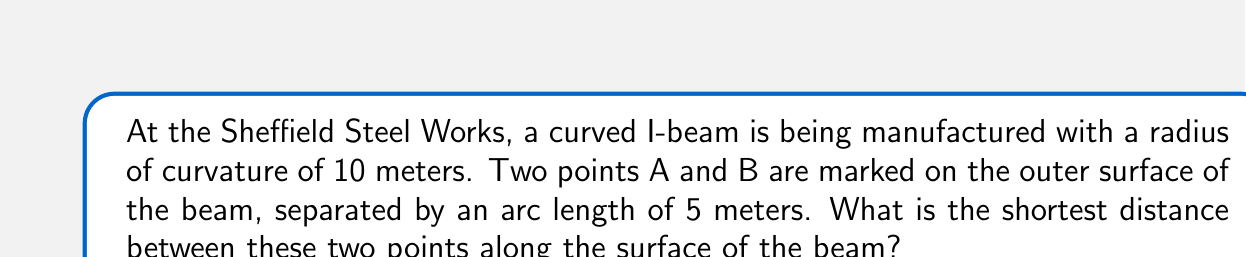Show me your answer to this math problem. Let's approach this step-by-step:

1) The beam's surface can be modeled as a section of a cylinder. The shortest path between two points on a cylindrical surface is a geodesic, which is a helix in this case.

2) We can "unwrap" the cylinder to a flat plane. In this plane, the shortest path becomes a straight line.

3) Let $r$ be the radius of the cylinder (beam) and $s$ be the arc length between points A and B. We're given:
   $r = 10$ meters
   $s = 5$ meters

4) The angle $\theta$ subtended by the arc at the center is:
   $$\theta = \frac{s}{r} = \frac{5}{10} = 0.5 \text{ radians}$$

5) In the "unwrapped" plane, this forms a right triangle where:
   - The base is the arc length: $s = 5$ meters
   - The height is the "unwrapped" circumferential distance: $r\theta = 10 * 0.5 = 5$ meters

6) The shortest path is the hypotenuse of this triangle. We can find it using the Pythagorean theorem:

   $$d = \sqrt{s^2 + (r\theta)^2} = \sqrt{5^2 + 5^2} = \sqrt{50} = 5\sqrt{2} \text{ meters}$$

Therefore, the shortest distance between the two points along the surface of the beam is $5\sqrt{2}$ meters.
Answer: $5\sqrt{2}$ meters 